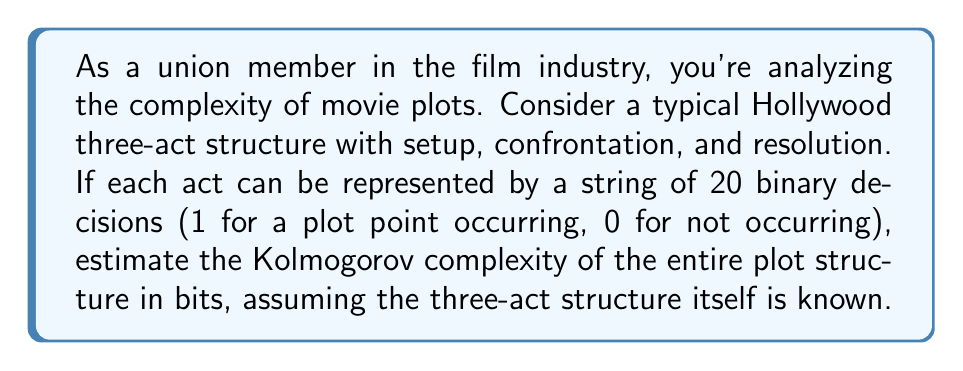Can you answer this question? To estimate the Kolmogorov complexity of the film's plot structure, we need to consider the following:

1. The three-act structure is given, so we don't need to account for its description.

2. Each act is represented by 20 binary decisions, so we have 3 acts * 20 decisions = 60 total decisions.

3. The Kolmogorov complexity is the length of the shortest program that can produce the given string. In this case, we're looking for the most compact way to describe the 60-bit string representing the plot structure.

4. If the plot structure was completely random, the Kolmogorov complexity would be close to 60 bits (the length of the string itself).

5. However, movie plots typically have patterns and structures that can be compressed. We can assume some level of compressibility due to:
   - Recurring themes or motifs
   - Character arcs that follow predictable patterns
   - Cause-and-effect relationships between plot points

6. A reasonable estimate for compressibility in this context might be around 25-30%. This means we could potentially describe the plot structure in about 70-75% of the original bit length.

7. Calculation:
   $$ \text{Estimated Kolmogorov complexity} = 60 \text{ bits} * (1 - 0.275) $$
   $$ = 60 * 0.725 = 43.5 \text{ bits} $$

8. Since we're estimating and Kolmogorov complexity is typically expressed in whole bits, we can round this to 44 bits.

This estimate suggests that the plot structure, while complex, has enough inherent patterns and structure to allow for some compression in its description.
Answer: 44 bits 